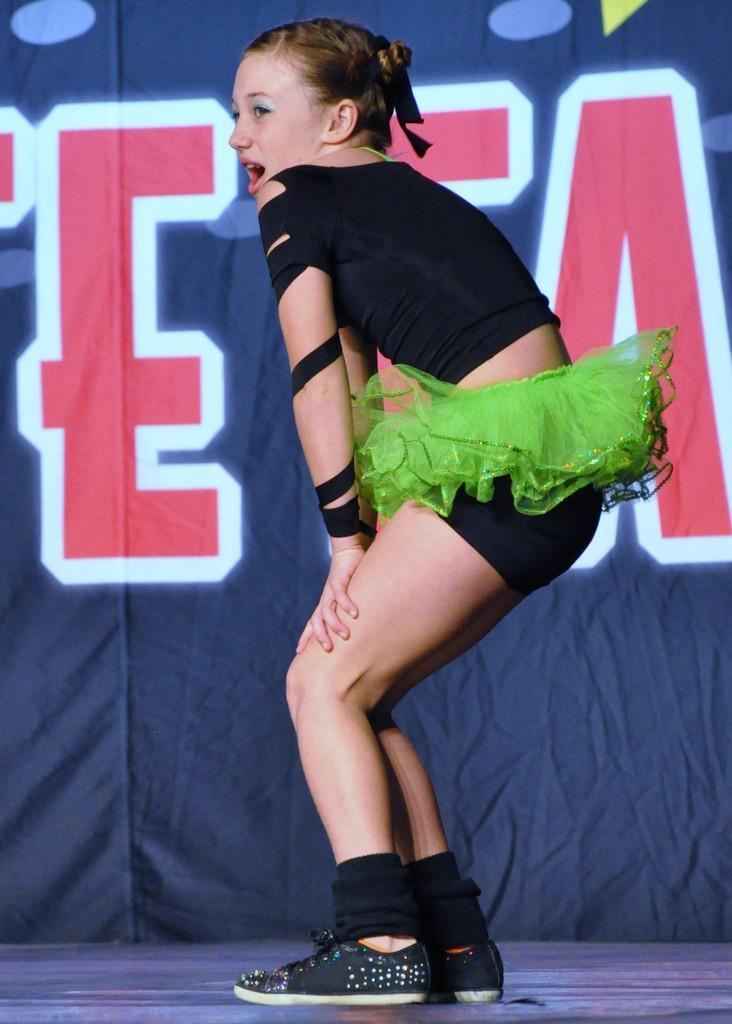Describe this image in one or two sentences. In the center of the image there is a girl. In the background of the image there is a cloth. At the bottom of the image there is floor. 